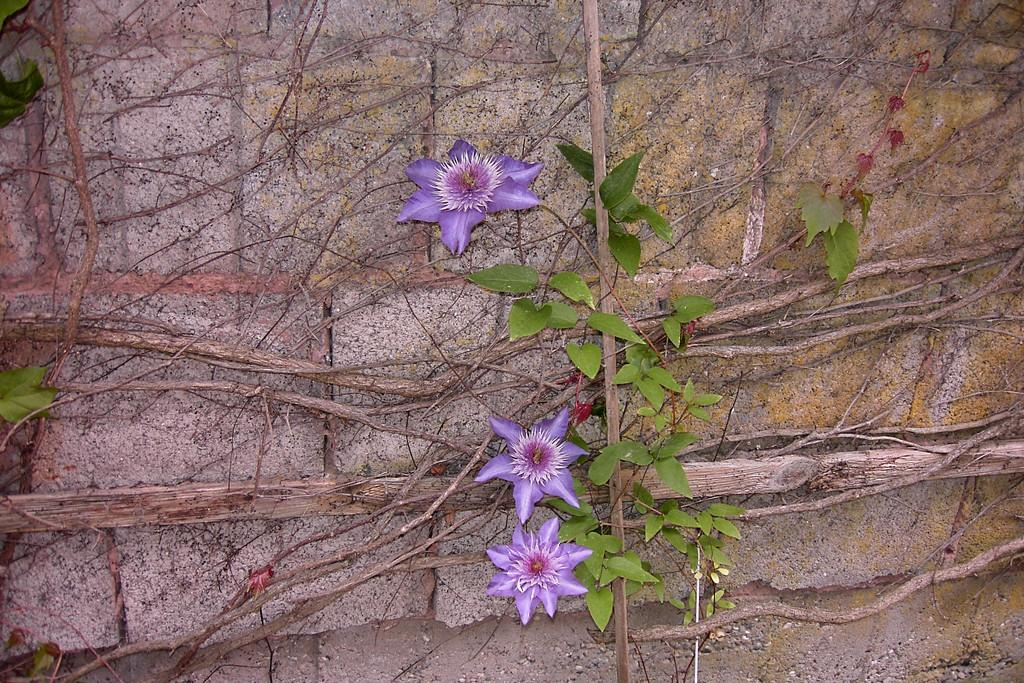What type of plants can be seen in the image? There are flowers in the image. What other part of the plants can be seen in the image? There are leaves in the image. Do the leaves appear to be attached to the plants? Yes, the leaves have roots in the image. Where are these plants located in the image? These elements are on a wall in the image. What type of decision can be heard being made in the image? There is no audible decision-making process present in the image, as it is a still image. How does the person in the image control the plants? There is no person present in the image, and the plants are not being controlled. 